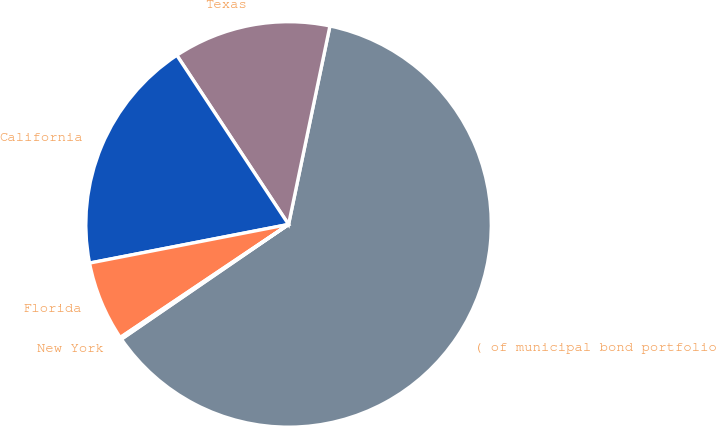Convert chart to OTSL. <chart><loc_0><loc_0><loc_500><loc_500><pie_chart><fcel>( of municipal bond portfolio<fcel>Texas<fcel>California<fcel>Florida<fcel>New York<nl><fcel>62.15%<fcel>12.56%<fcel>18.76%<fcel>6.36%<fcel>0.16%<nl></chart> 